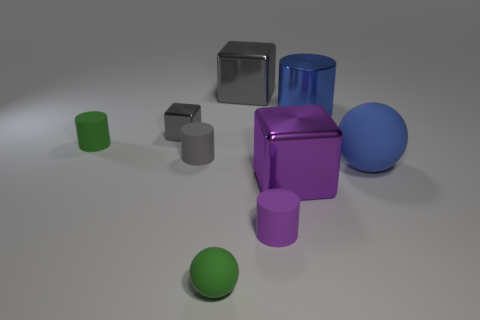What number of things are either big cubes that are in front of the tiny gray block or big cubes?
Provide a succinct answer. 2. There is a purple thing that is the same size as the blue metal thing; what material is it?
Offer a very short reply. Metal. The rubber sphere on the left side of the big metal cube that is behind the blue shiny thing is what color?
Offer a very short reply. Green. There is a small gray shiny object; how many small gray shiny blocks are in front of it?
Your response must be concise. 0. What is the color of the large cylinder?
Give a very brief answer. Blue. How many small things are blue matte balls or metallic cylinders?
Offer a very short reply. 0. There is a matte thing behind the gray cylinder; is it the same color as the sphere that is in front of the big purple metal object?
Offer a terse response. Yes. What number of other things are the same color as the small rubber sphere?
Your answer should be compact. 1. The green thing in front of the blue sphere has what shape?
Your answer should be compact. Sphere. Is the number of tiny gray cylinders less than the number of red cubes?
Ensure brevity in your answer.  No. 